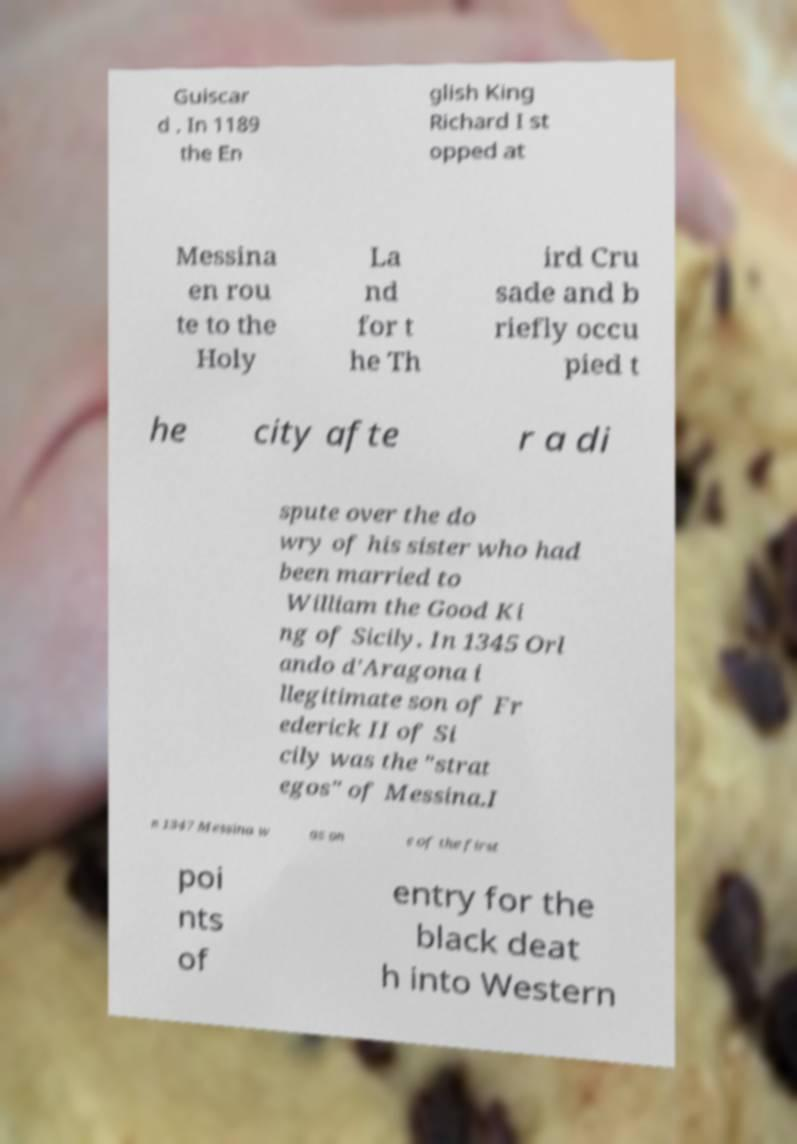I need the written content from this picture converted into text. Can you do that? Guiscar d . In 1189 the En glish King Richard I st opped at Messina en rou te to the Holy La nd for t he Th ird Cru sade and b riefly occu pied t he city afte r a di spute over the do wry of his sister who had been married to William the Good Ki ng of Sicily. In 1345 Orl ando d'Aragona i llegitimate son of Fr ederick II of Si cily was the "strat egos" of Messina.I n 1347 Messina w as on e of the first poi nts of entry for the black deat h into Western 